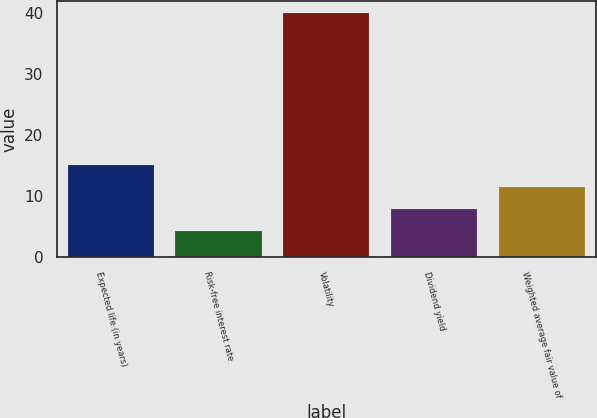<chart> <loc_0><loc_0><loc_500><loc_500><bar_chart><fcel>Expected life (in years)<fcel>Risk-free interest rate<fcel>Volatility<fcel>Dividend yield<fcel>Weighted average fair value of<nl><fcel>15.05<fcel>4.37<fcel>40<fcel>7.93<fcel>11.49<nl></chart> 